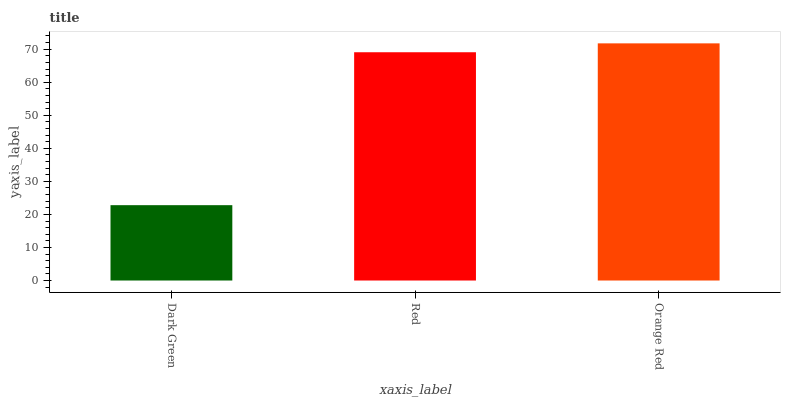Is Dark Green the minimum?
Answer yes or no. Yes. Is Orange Red the maximum?
Answer yes or no. Yes. Is Red the minimum?
Answer yes or no. No. Is Red the maximum?
Answer yes or no. No. Is Red greater than Dark Green?
Answer yes or no. Yes. Is Dark Green less than Red?
Answer yes or no. Yes. Is Dark Green greater than Red?
Answer yes or no. No. Is Red less than Dark Green?
Answer yes or no. No. Is Red the high median?
Answer yes or no. Yes. Is Red the low median?
Answer yes or no. Yes. Is Orange Red the high median?
Answer yes or no. No. Is Orange Red the low median?
Answer yes or no. No. 